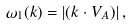Convert formula to latex. <formula><loc_0><loc_0><loc_500><loc_500>\omega _ { 1 } ( k ) = | ( { k \cdot V } _ { A } ) | \, ,</formula> 